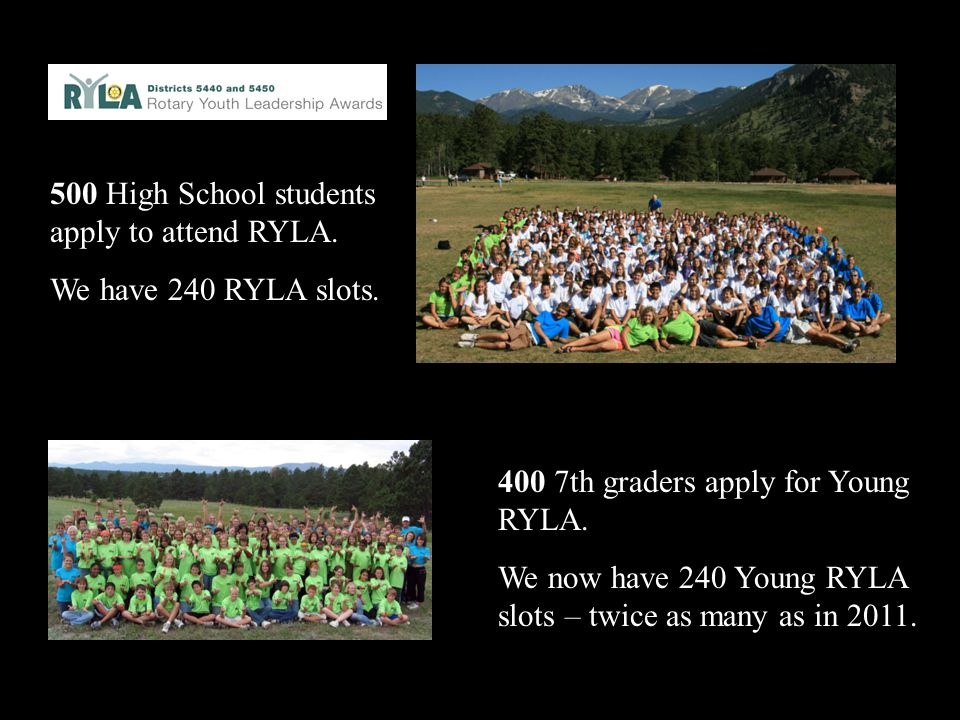Pretend that a new character from a fantasy world joins the camp. Describe their background and how they might influence the events at the camp. Imagine a character named Elara, a young elf from the enchanted forest of Mistwood, joining the Young RYLA camp. Elara is endowed with ancient wisdom and magical abilities, having spent years learning from the elders of her realm. Her background is rich with tales of mythical creatures, forest spirits, and legendary quests. At the camp, Elara's presence would be awe-inspiring and mystical, capturing the imagination of all the participants. She would introduce new ways of thinking, blending her magical insights with contemporary leadership principles. Elara might lead nature walks where she teaches the campers to communicate with wildlife, demonstrating the importance of harmony and empathy. Her unique perspective on leadership, centered on balance, intuition, and deep respect for nature, would inspire the campers to consider broader, more holistic approaches to problem-solving and teamwork. Elara's stories and wisdom would leave a lasting impression, adding a magical element to the camp that participants would remember for years. 